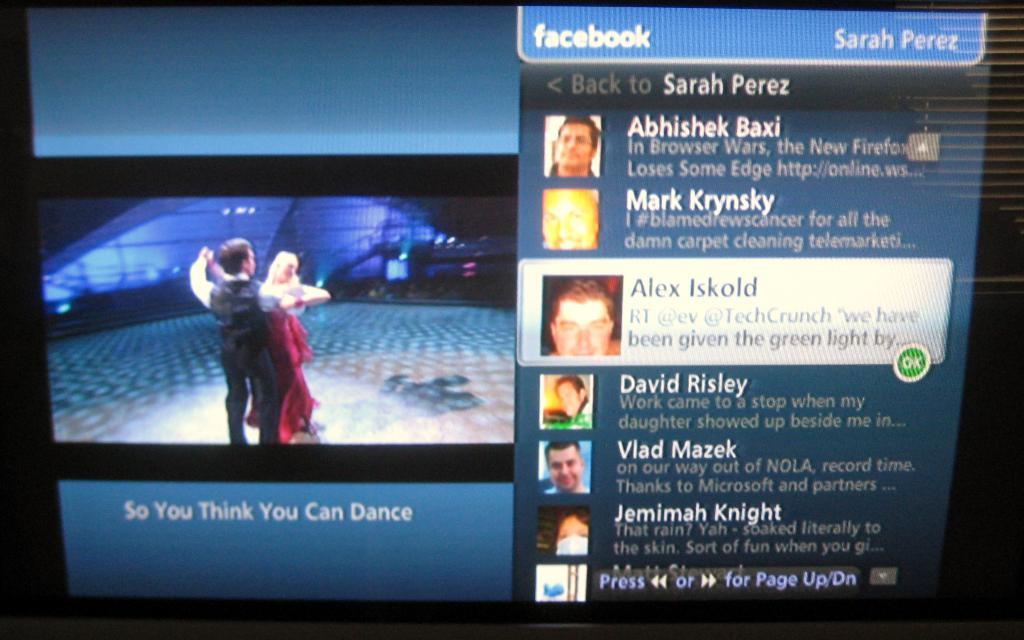What show are they watching?
Provide a succinct answer. So you think you can dance. What platform is at the top?
Give a very brief answer. Facebook. 